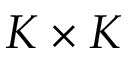Convert formula to latex. <formula><loc_0><loc_0><loc_500><loc_500>K \times K</formula> 